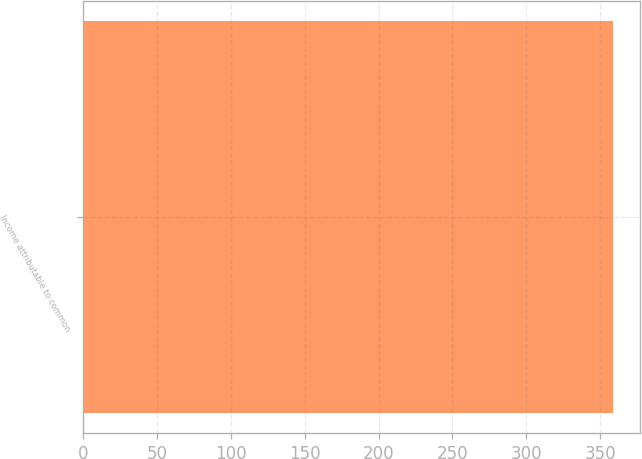Convert chart. <chart><loc_0><loc_0><loc_500><loc_500><bar_chart><fcel>Income attributable to common<nl><fcel>359<nl></chart> 